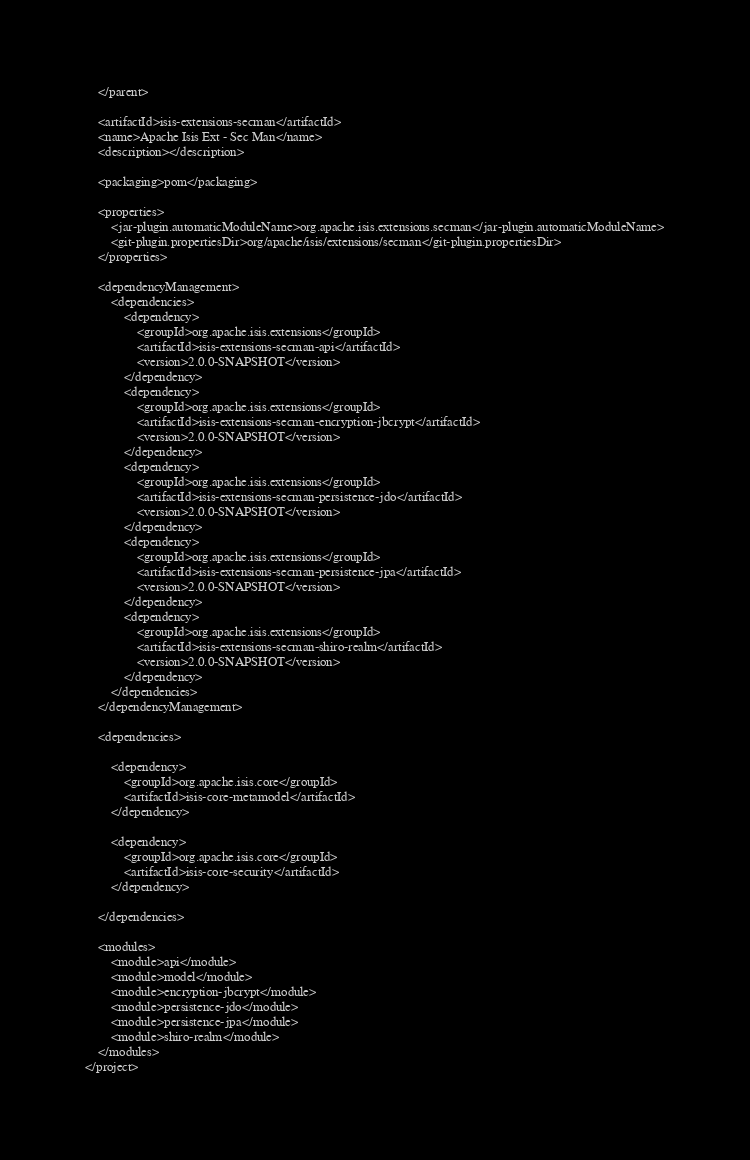Convert code to text. <code><loc_0><loc_0><loc_500><loc_500><_XML_>    </parent>

    <artifactId>isis-extensions-secman</artifactId>
    <name>Apache Isis Ext - Sec Man</name>
    <description></description>
    
    <packaging>pom</packaging>

    <properties>
        <jar-plugin.automaticModuleName>org.apache.isis.extensions.secman</jar-plugin.automaticModuleName>
        <git-plugin.propertiesDir>org/apache/isis/extensions/secman</git-plugin.propertiesDir>
    </properties>

    <dependencyManagement>
        <dependencies>
            <dependency>
                <groupId>org.apache.isis.extensions</groupId>
                <artifactId>isis-extensions-secman-api</artifactId>
                <version>2.0.0-SNAPSHOT</version>
            </dependency>
            <dependency>
                <groupId>org.apache.isis.extensions</groupId>
                <artifactId>isis-extensions-secman-encryption-jbcrypt</artifactId>
                <version>2.0.0-SNAPSHOT</version>
            </dependency>
            <dependency>
                <groupId>org.apache.isis.extensions</groupId>
                <artifactId>isis-extensions-secman-persistence-jdo</artifactId>
                <version>2.0.0-SNAPSHOT</version>
            </dependency>
            <dependency>
                <groupId>org.apache.isis.extensions</groupId>
                <artifactId>isis-extensions-secman-persistence-jpa</artifactId>
                <version>2.0.0-SNAPSHOT</version>
            </dependency>
            <dependency>
                <groupId>org.apache.isis.extensions</groupId>
                <artifactId>isis-extensions-secman-shiro-realm</artifactId>
                <version>2.0.0-SNAPSHOT</version>
            </dependency>
        </dependencies>
    </dependencyManagement>

    <dependencies>
	
		<dependency>
			<groupId>org.apache.isis.core</groupId>
			<artifactId>isis-core-metamodel</artifactId>
		</dependency>
	
		<dependency>
			<groupId>org.apache.isis.core</groupId>
			<artifactId>isis-core-security</artifactId>
		</dependency>

    </dependencies>

    <modules>
    	<module>api</module>
    	<module>model</module>
    	<module>encryption-jbcrypt</module>
    	<module>persistence-jdo</module>
    	<module>persistence-jpa</module>
    	<module>shiro-realm</module>
    </modules>
</project>
</code> 